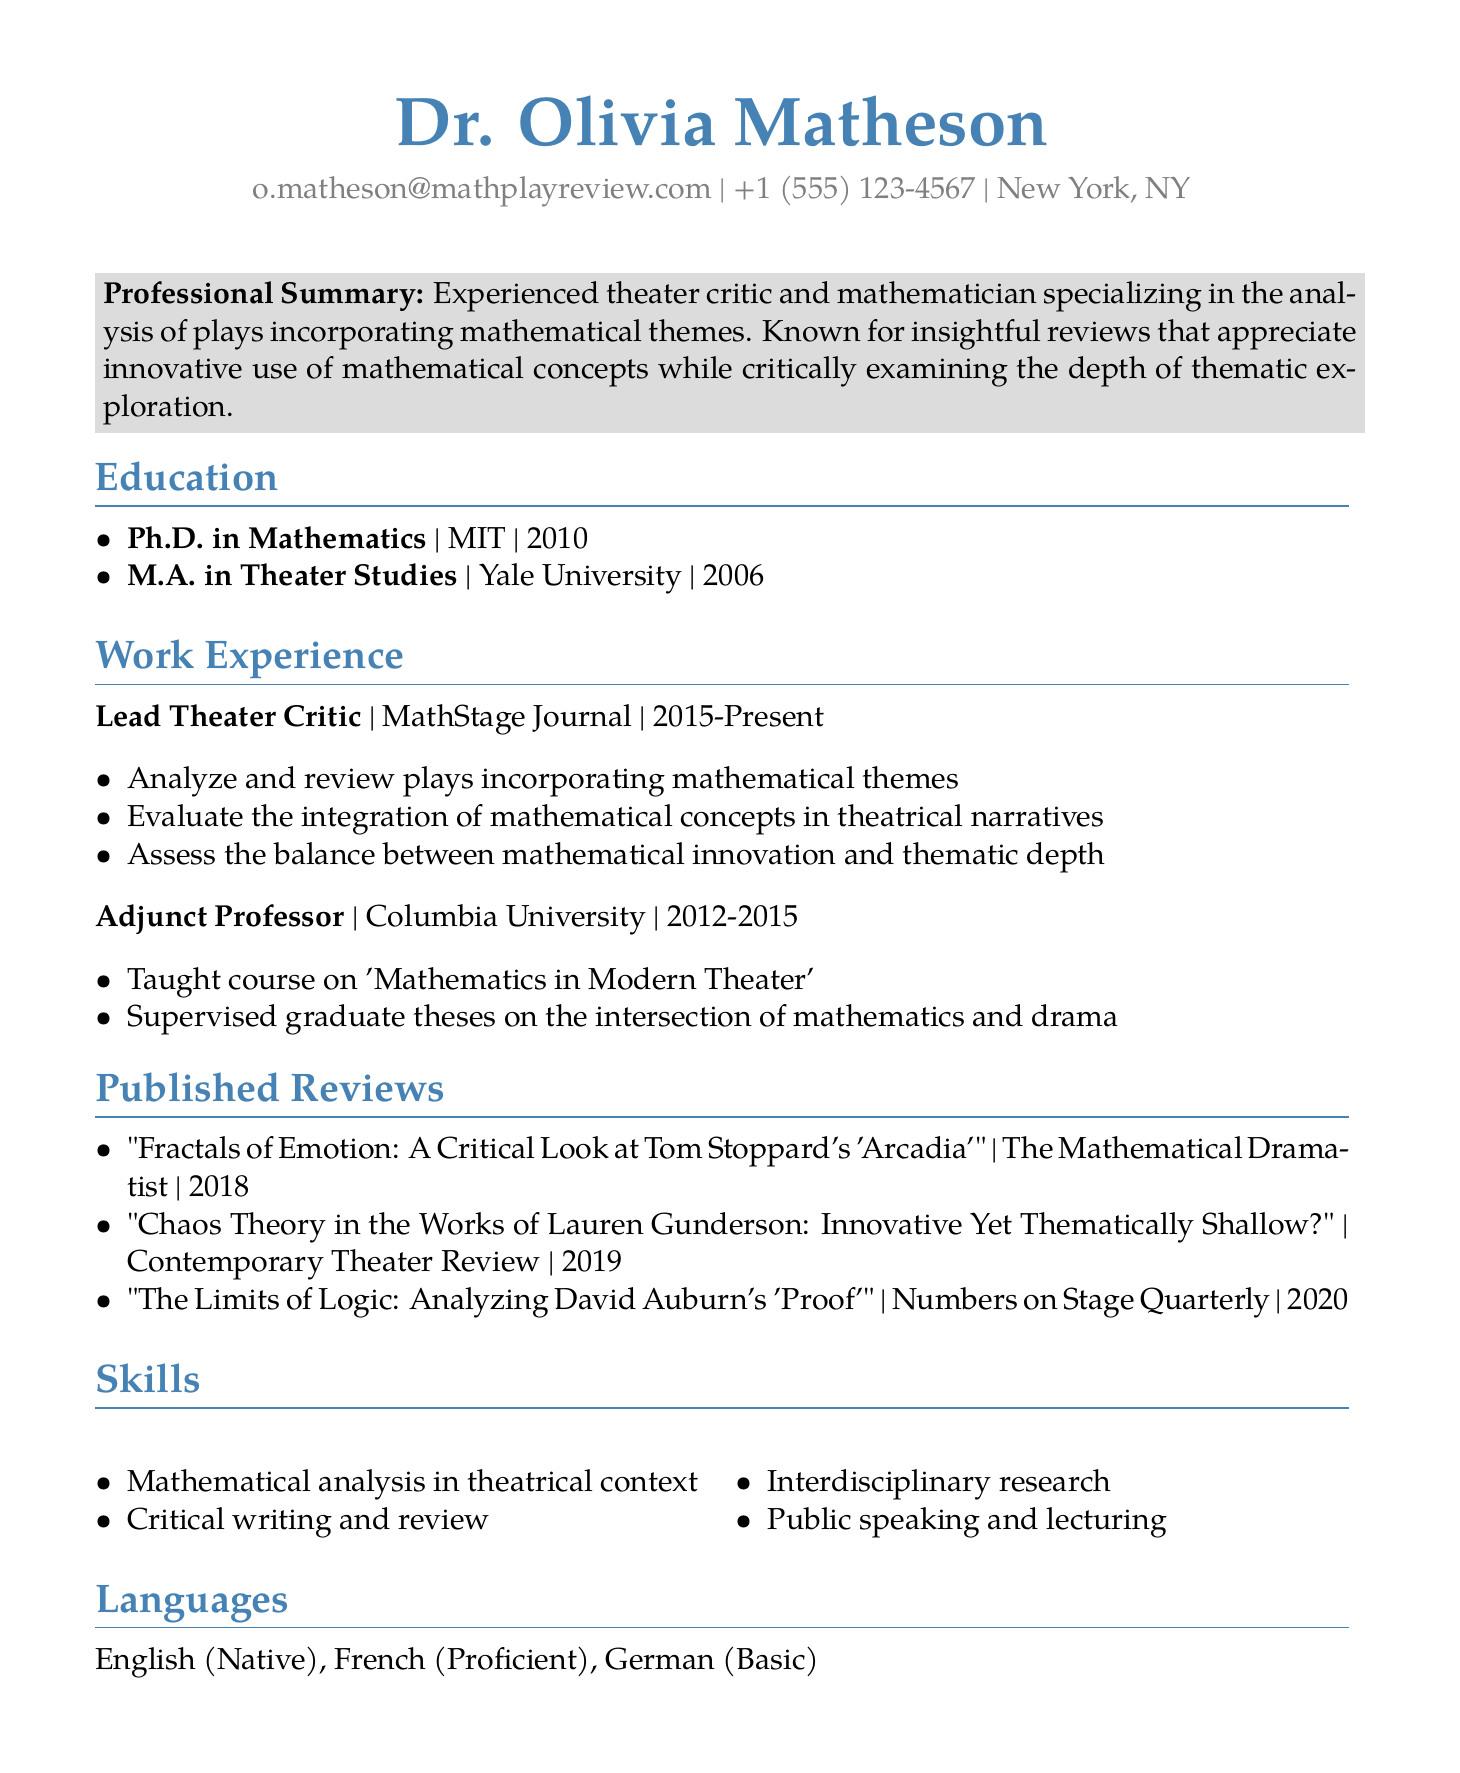What is the name of the Lead Theater Critic? The document states that Dr. Olivia Matheson is the Lead Theater Critic at MathStage Journal.
Answer: Dr. Olivia Matheson When did Dr. Matheson complete her Ph.D.? The document lists her Ph.D. in Mathematics from MIT was completed in 2010.
Answer: 2010 Which university did Dr. Matheson attend for her M.A. in Theater Studies? The document specifies she obtained her M.A. in Theater Studies from Yale University.
Answer: Yale University What is the title of Dr. Matheson's review published in 2019? The document indicates the title of the review is "Chaos Theory in the Works of Lauren Gunderson: Innovative Yet Thematically Shallow?"
Answer: Chaos Theory in the Works of Lauren Gunderson: Innovative Yet Thematically Shallow? How many years did Dr. Matheson work as an Adjunct Professor? The work experience section shows she worked from 2012 to 2015 which totals three years.
Answer: 3 years What are two languages Dr. Matheson is proficient in? The document lists English as her native language and French as proficient.
Answer: English, French What is the main focus of Dr. Matheson's professional summary? The summary emphasizes her expertise in analyzing plays that incorporate mathematical themes.
Answer: Analyzing plays with mathematical themes What skill related to communication does Dr. Matheson mention? The skills section includes public speaking and lecturing as part of her skill set.
Answer: Public speaking and lecturing What type of courses did Dr. Matheson teach at Columbia University? The document indicates she taught a course on "Mathematics in Modern Theater."
Answer: Mathematics in Modern Theater 